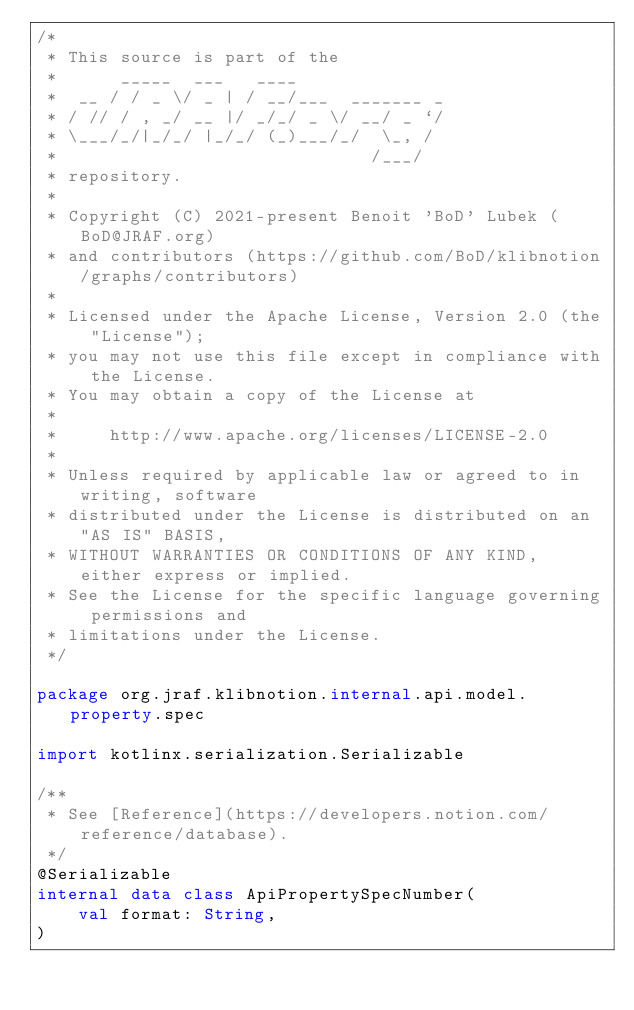<code> <loc_0><loc_0><loc_500><loc_500><_Kotlin_>/*
 * This source is part of the
 *      _____  ___   ____
 *  __ / / _ \/ _ | / __/___  _______ _
 * / // / , _/ __ |/ _/_/ _ \/ __/ _ `/
 * \___/_/|_/_/ |_/_/ (_)___/_/  \_, /
 *                              /___/
 * repository.
 *
 * Copyright (C) 2021-present Benoit 'BoD' Lubek (BoD@JRAF.org)
 * and contributors (https://github.com/BoD/klibnotion/graphs/contributors)
 *
 * Licensed under the Apache License, Version 2.0 (the "License");
 * you may not use this file except in compliance with the License.
 * You may obtain a copy of the License at
 *
 *     http://www.apache.org/licenses/LICENSE-2.0
 *
 * Unless required by applicable law or agreed to in writing, software
 * distributed under the License is distributed on an "AS IS" BASIS,
 * WITHOUT WARRANTIES OR CONDITIONS OF ANY KIND, either express or implied.
 * See the License for the specific language governing permissions and
 * limitations under the License.
 */

package org.jraf.klibnotion.internal.api.model.property.spec

import kotlinx.serialization.Serializable

/**
 * See [Reference](https://developers.notion.com/reference/database).
 */
@Serializable
internal data class ApiPropertySpecNumber(
    val format: String,
)
</code> 